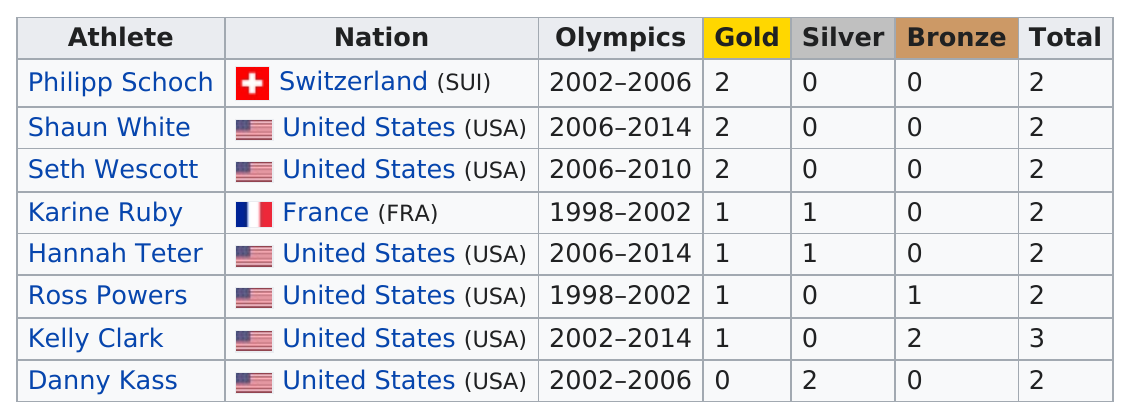Give some essential details in this illustration. Danny Kass, an athlete, has only won silver medals. Shaun White has won a total of two medals in snowboarding competitions. Kelly Clark has won the most total snowboarding medals of all time. Kelly Clark has earned the most medals. Kelly Clark has won the most bronze medals. 